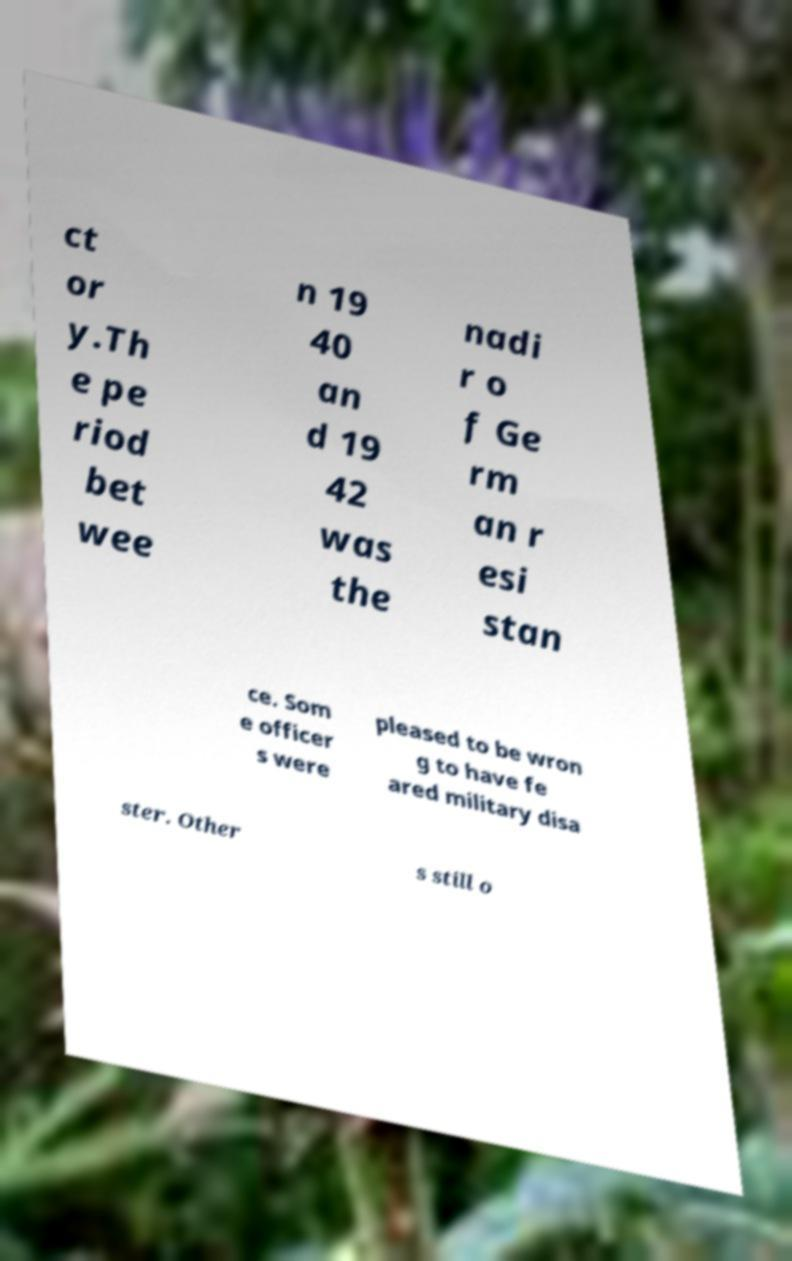Could you assist in decoding the text presented in this image and type it out clearly? ct or y.Th e pe riod bet wee n 19 40 an d 19 42 was the nadi r o f Ge rm an r esi stan ce. Som e officer s were pleased to be wron g to have fe ared military disa ster. Other s still o 